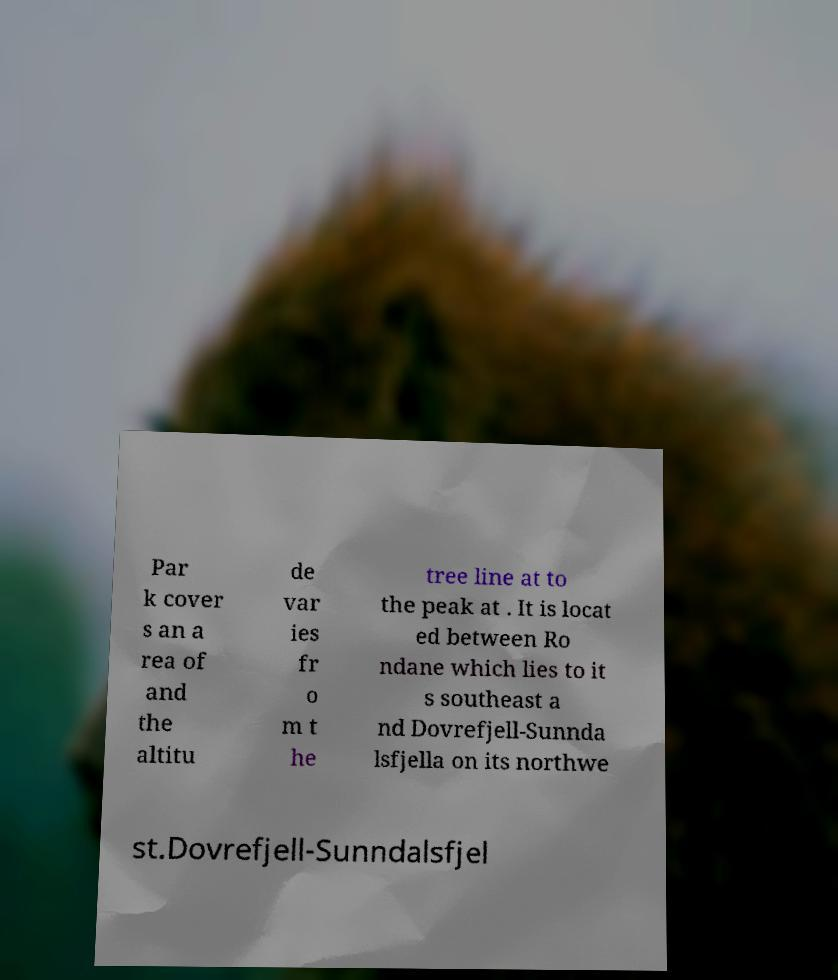Please identify and transcribe the text found in this image. Par k cover s an a rea of and the altitu de var ies fr o m t he tree line at to the peak at . It is locat ed between Ro ndane which lies to it s southeast a nd Dovrefjell-Sunnda lsfjella on its northwe st.Dovrefjell-Sunndalsfjel 